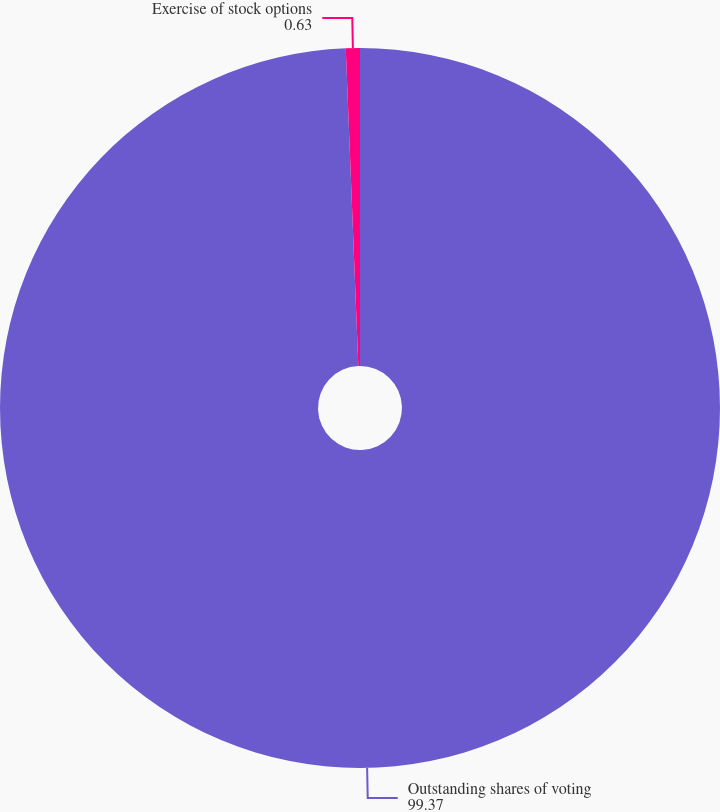Convert chart to OTSL. <chart><loc_0><loc_0><loc_500><loc_500><pie_chart><fcel>Outstanding shares of voting<fcel>Exercise of stock options<nl><fcel>99.37%<fcel>0.63%<nl></chart> 